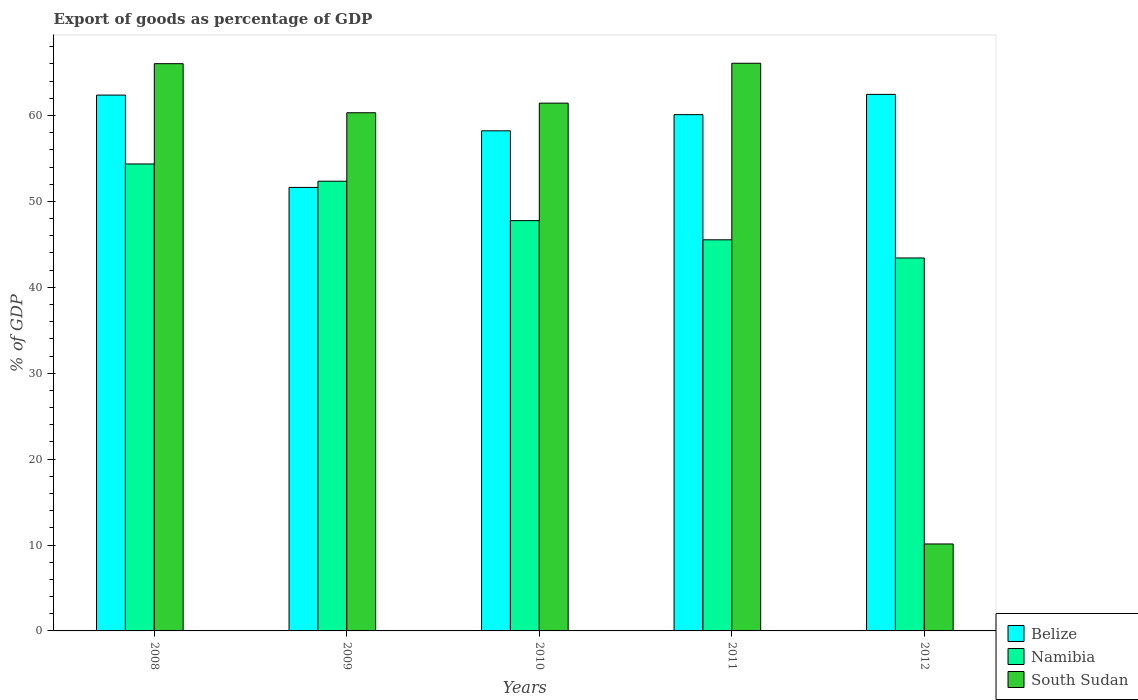How many different coloured bars are there?
Your response must be concise. 3. How many groups of bars are there?
Keep it short and to the point. 5. Are the number of bars per tick equal to the number of legend labels?
Your answer should be compact. Yes. Are the number of bars on each tick of the X-axis equal?
Ensure brevity in your answer.  Yes. How many bars are there on the 2nd tick from the right?
Keep it short and to the point. 3. What is the label of the 2nd group of bars from the left?
Ensure brevity in your answer.  2009. In how many cases, is the number of bars for a given year not equal to the number of legend labels?
Your response must be concise. 0. What is the export of goods as percentage of GDP in South Sudan in 2010?
Ensure brevity in your answer.  61.43. Across all years, what is the maximum export of goods as percentage of GDP in South Sudan?
Your answer should be very brief. 66.08. Across all years, what is the minimum export of goods as percentage of GDP in Namibia?
Keep it short and to the point. 43.41. In which year was the export of goods as percentage of GDP in South Sudan maximum?
Offer a terse response. 2011. What is the total export of goods as percentage of GDP in Namibia in the graph?
Your answer should be compact. 243.4. What is the difference between the export of goods as percentage of GDP in Namibia in 2008 and that in 2011?
Provide a short and direct response. 8.83. What is the difference between the export of goods as percentage of GDP in Belize in 2011 and the export of goods as percentage of GDP in South Sudan in 2010?
Your answer should be compact. -1.34. What is the average export of goods as percentage of GDP in Belize per year?
Your answer should be very brief. 58.95. In the year 2008, what is the difference between the export of goods as percentage of GDP in Namibia and export of goods as percentage of GDP in Belize?
Your response must be concise. -8.02. What is the ratio of the export of goods as percentage of GDP in Belize in 2009 to that in 2011?
Your response must be concise. 0.86. Is the difference between the export of goods as percentage of GDP in Namibia in 2011 and 2012 greater than the difference between the export of goods as percentage of GDP in Belize in 2011 and 2012?
Your answer should be very brief. Yes. What is the difference between the highest and the second highest export of goods as percentage of GDP in Namibia?
Keep it short and to the point. 2.01. What is the difference between the highest and the lowest export of goods as percentage of GDP in Namibia?
Ensure brevity in your answer.  10.94. In how many years, is the export of goods as percentage of GDP in South Sudan greater than the average export of goods as percentage of GDP in South Sudan taken over all years?
Your response must be concise. 4. Is the sum of the export of goods as percentage of GDP in Namibia in 2008 and 2010 greater than the maximum export of goods as percentage of GDP in Belize across all years?
Ensure brevity in your answer.  Yes. What does the 1st bar from the left in 2010 represents?
Provide a short and direct response. Belize. What does the 2nd bar from the right in 2009 represents?
Your response must be concise. Namibia. Is it the case that in every year, the sum of the export of goods as percentage of GDP in South Sudan and export of goods as percentage of GDP in Belize is greater than the export of goods as percentage of GDP in Namibia?
Make the answer very short. Yes. Are all the bars in the graph horizontal?
Your answer should be very brief. No. How many years are there in the graph?
Your answer should be very brief. 5. Does the graph contain grids?
Keep it short and to the point. No. Where does the legend appear in the graph?
Offer a very short reply. Bottom right. How many legend labels are there?
Keep it short and to the point. 3. How are the legend labels stacked?
Provide a succinct answer. Vertical. What is the title of the graph?
Provide a short and direct response. Export of goods as percentage of GDP. Does "Indonesia" appear as one of the legend labels in the graph?
Keep it short and to the point. No. What is the label or title of the Y-axis?
Give a very brief answer. % of GDP. What is the % of GDP in Belize in 2008?
Your response must be concise. 62.37. What is the % of GDP of Namibia in 2008?
Make the answer very short. 54.35. What is the % of GDP in South Sudan in 2008?
Your answer should be very brief. 66.03. What is the % of GDP in Belize in 2009?
Your answer should be very brief. 51.62. What is the % of GDP in Namibia in 2009?
Your answer should be very brief. 52.35. What is the % of GDP of South Sudan in 2009?
Your response must be concise. 60.31. What is the % of GDP in Belize in 2010?
Ensure brevity in your answer.  58.21. What is the % of GDP in Namibia in 2010?
Ensure brevity in your answer.  47.76. What is the % of GDP in South Sudan in 2010?
Offer a very short reply. 61.43. What is the % of GDP of Belize in 2011?
Provide a succinct answer. 60.09. What is the % of GDP of Namibia in 2011?
Keep it short and to the point. 45.53. What is the % of GDP of South Sudan in 2011?
Keep it short and to the point. 66.08. What is the % of GDP in Belize in 2012?
Your answer should be very brief. 62.45. What is the % of GDP of Namibia in 2012?
Your response must be concise. 43.41. What is the % of GDP of South Sudan in 2012?
Provide a short and direct response. 10.12. Across all years, what is the maximum % of GDP in Belize?
Provide a succinct answer. 62.45. Across all years, what is the maximum % of GDP of Namibia?
Offer a terse response. 54.35. Across all years, what is the maximum % of GDP in South Sudan?
Your response must be concise. 66.08. Across all years, what is the minimum % of GDP in Belize?
Make the answer very short. 51.62. Across all years, what is the minimum % of GDP of Namibia?
Make the answer very short. 43.41. Across all years, what is the minimum % of GDP of South Sudan?
Keep it short and to the point. 10.12. What is the total % of GDP in Belize in the graph?
Ensure brevity in your answer.  294.75. What is the total % of GDP of Namibia in the graph?
Ensure brevity in your answer.  243.4. What is the total % of GDP in South Sudan in the graph?
Ensure brevity in your answer.  263.97. What is the difference between the % of GDP in Belize in 2008 and that in 2009?
Your answer should be compact. 10.75. What is the difference between the % of GDP in Namibia in 2008 and that in 2009?
Offer a very short reply. 2.01. What is the difference between the % of GDP in South Sudan in 2008 and that in 2009?
Offer a very short reply. 5.71. What is the difference between the % of GDP in Belize in 2008 and that in 2010?
Your answer should be compact. 4.16. What is the difference between the % of GDP of Namibia in 2008 and that in 2010?
Keep it short and to the point. 6.6. What is the difference between the % of GDP of South Sudan in 2008 and that in 2010?
Offer a terse response. 4.59. What is the difference between the % of GDP in Belize in 2008 and that in 2011?
Provide a succinct answer. 2.28. What is the difference between the % of GDP of Namibia in 2008 and that in 2011?
Keep it short and to the point. 8.83. What is the difference between the % of GDP of South Sudan in 2008 and that in 2011?
Keep it short and to the point. -0.05. What is the difference between the % of GDP in Belize in 2008 and that in 2012?
Give a very brief answer. -0.08. What is the difference between the % of GDP of Namibia in 2008 and that in 2012?
Keep it short and to the point. 10.94. What is the difference between the % of GDP in South Sudan in 2008 and that in 2012?
Offer a terse response. 55.91. What is the difference between the % of GDP of Belize in 2009 and that in 2010?
Give a very brief answer. -6.59. What is the difference between the % of GDP of Namibia in 2009 and that in 2010?
Make the answer very short. 4.59. What is the difference between the % of GDP of South Sudan in 2009 and that in 2010?
Offer a terse response. -1.12. What is the difference between the % of GDP in Belize in 2009 and that in 2011?
Offer a very short reply. -8.47. What is the difference between the % of GDP of Namibia in 2009 and that in 2011?
Make the answer very short. 6.82. What is the difference between the % of GDP of South Sudan in 2009 and that in 2011?
Provide a succinct answer. -5.76. What is the difference between the % of GDP of Belize in 2009 and that in 2012?
Offer a terse response. -10.83. What is the difference between the % of GDP in Namibia in 2009 and that in 2012?
Your response must be concise. 8.94. What is the difference between the % of GDP in South Sudan in 2009 and that in 2012?
Provide a succinct answer. 50.19. What is the difference between the % of GDP of Belize in 2010 and that in 2011?
Offer a terse response. -1.88. What is the difference between the % of GDP of Namibia in 2010 and that in 2011?
Your response must be concise. 2.23. What is the difference between the % of GDP in South Sudan in 2010 and that in 2011?
Offer a very short reply. -4.64. What is the difference between the % of GDP in Belize in 2010 and that in 2012?
Your answer should be compact. -4.24. What is the difference between the % of GDP of Namibia in 2010 and that in 2012?
Keep it short and to the point. 4.35. What is the difference between the % of GDP in South Sudan in 2010 and that in 2012?
Keep it short and to the point. 51.31. What is the difference between the % of GDP in Belize in 2011 and that in 2012?
Offer a terse response. -2.36. What is the difference between the % of GDP in Namibia in 2011 and that in 2012?
Give a very brief answer. 2.12. What is the difference between the % of GDP of South Sudan in 2011 and that in 2012?
Make the answer very short. 55.95. What is the difference between the % of GDP of Belize in 2008 and the % of GDP of Namibia in 2009?
Your answer should be compact. 10.02. What is the difference between the % of GDP of Belize in 2008 and the % of GDP of South Sudan in 2009?
Offer a very short reply. 2.06. What is the difference between the % of GDP in Namibia in 2008 and the % of GDP in South Sudan in 2009?
Offer a very short reply. -5.96. What is the difference between the % of GDP in Belize in 2008 and the % of GDP in Namibia in 2010?
Provide a succinct answer. 14.61. What is the difference between the % of GDP of Belize in 2008 and the % of GDP of South Sudan in 2010?
Your answer should be compact. 0.94. What is the difference between the % of GDP in Namibia in 2008 and the % of GDP in South Sudan in 2010?
Ensure brevity in your answer.  -7.08. What is the difference between the % of GDP in Belize in 2008 and the % of GDP in Namibia in 2011?
Your answer should be compact. 16.85. What is the difference between the % of GDP in Belize in 2008 and the % of GDP in South Sudan in 2011?
Ensure brevity in your answer.  -3.7. What is the difference between the % of GDP of Namibia in 2008 and the % of GDP of South Sudan in 2011?
Make the answer very short. -11.72. What is the difference between the % of GDP of Belize in 2008 and the % of GDP of Namibia in 2012?
Provide a succinct answer. 18.96. What is the difference between the % of GDP of Belize in 2008 and the % of GDP of South Sudan in 2012?
Offer a very short reply. 52.25. What is the difference between the % of GDP in Namibia in 2008 and the % of GDP in South Sudan in 2012?
Offer a very short reply. 44.23. What is the difference between the % of GDP of Belize in 2009 and the % of GDP of Namibia in 2010?
Provide a succinct answer. 3.87. What is the difference between the % of GDP of Belize in 2009 and the % of GDP of South Sudan in 2010?
Offer a very short reply. -9.81. What is the difference between the % of GDP in Namibia in 2009 and the % of GDP in South Sudan in 2010?
Offer a very short reply. -9.09. What is the difference between the % of GDP in Belize in 2009 and the % of GDP in Namibia in 2011?
Your response must be concise. 6.1. What is the difference between the % of GDP in Belize in 2009 and the % of GDP in South Sudan in 2011?
Your answer should be compact. -14.45. What is the difference between the % of GDP of Namibia in 2009 and the % of GDP of South Sudan in 2011?
Provide a short and direct response. -13.73. What is the difference between the % of GDP of Belize in 2009 and the % of GDP of Namibia in 2012?
Your answer should be very brief. 8.21. What is the difference between the % of GDP of Belize in 2009 and the % of GDP of South Sudan in 2012?
Provide a succinct answer. 41.5. What is the difference between the % of GDP in Namibia in 2009 and the % of GDP in South Sudan in 2012?
Your answer should be compact. 42.23. What is the difference between the % of GDP of Belize in 2010 and the % of GDP of Namibia in 2011?
Offer a very short reply. 12.69. What is the difference between the % of GDP of Belize in 2010 and the % of GDP of South Sudan in 2011?
Offer a terse response. -7.86. What is the difference between the % of GDP in Namibia in 2010 and the % of GDP in South Sudan in 2011?
Make the answer very short. -18.32. What is the difference between the % of GDP in Belize in 2010 and the % of GDP in Namibia in 2012?
Offer a terse response. 14.8. What is the difference between the % of GDP in Belize in 2010 and the % of GDP in South Sudan in 2012?
Your answer should be compact. 48.09. What is the difference between the % of GDP of Namibia in 2010 and the % of GDP of South Sudan in 2012?
Make the answer very short. 37.64. What is the difference between the % of GDP of Belize in 2011 and the % of GDP of Namibia in 2012?
Your answer should be compact. 16.68. What is the difference between the % of GDP in Belize in 2011 and the % of GDP in South Sudan in 2012?
Make the answer very short. 49.97. What is the difference between the % of GDP in Namibia in 2011 and the % of GDP in South Sudan in 2012?
Your answer should be compact. 35.4. What is the average % of GDP in Belize per year?
Your answer should be compact. 58.95. What is the average % of GDP of Namibia per year?
Provide a short and direct response. 48.68. What is the average % of GDP in South Sudan per year?
Give a very brief answer. 52.79. In the year 2008, what is the difference between the % of GDP of Belize and % of GDP of Namibia?
Your response must be concise. 8.02. In the year 2008, what is the difference between the % of GDP in Belize and % of GDP in South Sudan?
Give a very brief answer. -3.66. In the year 2008, what is the difference between the % of GDP in Namibia and % of GDP in South Sudan?
Offer a terse response. -11.67. In the year 2009, what is the difference between the % of GDP in Belize and % of GDP in Namibia?
Keep it short and to the point. -0.72. In the year 2009, what is the difference between the % of GDP of Belize and % of GDP of South Sudan?
Your answer should be very brief. -8.69. In the year 2009, what is the difference between the % of GDP of Namibia and % of GDP of South Sudan?
Provide a succinct answer. -7.97. In the year 2010, what is the difference between the % of GDP of Belize and % of GDP of Namibia?
Provide a short and direct response. 10.46. In the year 2010, what is the difference between the % of GDP of Belize and % of GDP of South Sudan?
Make the answer very short. -3.22. In the year 2010, what is the difference between the % of GDP in Namibia and % of GDP in South Sudan?
Keep it short and to the point. -13.68. In the year 2011, what is the difference between the % of GDP of Belize and % of GDP of Namibia?
Provide a short and direct response. 14.57. In the year 2011, what is the difference between the % of GDP in Belize and % of GDP in South Sudan?
Ensure brevity in your answer.  -5.98. In the year 2011, what is the difference between the % of GDP of Namibia and % of GDP of South Sudan?
Give a very brief answer. -20.55. In the year 2012, what is the difference between the % of GDP in Belize and % of GDP in Namibia?
Provide a short and direct response. 19.04. In the year 2012, what is the difference between the % of GDP of Belize and % of GDP of South Sudan?
Your answer should be compact. 52.33. In the year 2012, what is the difference between the % of GDP of Namibia and % of GDP of South Sudan?
Make the answer very short. 33.29. What is the ratio of the % of GDP in Belize in 2008 to that in 2009?
Give a very brief answer. 1.21. What is the ratio of the % of GDP of Namibia in 2008 to that in 2009?
Your response must be concise. 1.04. What is the ratio of the % of GDP in South Sudan in 2008 to that in 2009?
Provide a short and direct response. 1.09. What is the ratio of the % of GDP in Belize in 2008 to that in 2010?
Offer a terse response. 1.07. What is the ratio of the % of GDP of Namibia in 2008 to that in 2010?
Provide a succinct answer. 1.14. What is the ratio of the % of GDP of South Sudan in 2008 to that in 2010?
Provide a succinct answer. 1.07. What is the ratio of the % of GDP in Belize in 2008 to that in 2011?
Make the answer very short. 1.04. What is the ratio of the % of GDP in Namibia in 2008 to that in 2011?
Provide a short and direct response. 1.19. What is the ratio of the % of GDP in Belize in 2008 to that in 2012?
Give a very brief answer. 1. What is the ratio of the % of GDP of Namibia in 2008 to that in 2012?
Keep it short and to the point. 1.25. What is the ratio of the % of GDP of South Sudan in 2008 to that in 2012?
Provide a short and direct response. 6.52. What is the ratio of the % of GDP of Belize in 2009 to that in 2010?
Your answer should be compact. 0.89. What is the ratio of the % of GDP of Namibia in 2009 to that in 2010?
Make the answer very short. 1.1. What is the ratio of the % of GDP in South Sudan in 2009 to that in 2010?
Keep it short and to the point. 0.98. What is the ratio of the % of GDP in Belize in 2009 to that in 2011?
Your answer should be compact. 0.86. What is the ratio of the % of GDP in Namibia in 2009 to that in 2011?
Ensure brevity in your answer.  1.15. What is the ratio of the % of GDP in South Sudan in 2009 to that in 2011?
Offer a terse response. 0.91. What is the ratio of the % of GDP in Belize in 2009 to that in 2012?
Your answer should be compact. 0.83. What is the ratio of the % of GDP in Namibia in 2009 to that in 2012?
Your answer should be very brief. 1.21. What is the ratio of the % of GDP of South Sudan in 2009 to that in 2012?
Your answer should be very brief. 5.96. What is the ratio of the % of GDP in Belize in 2010 to that in 2011?
Ensure brevity in your answer.  0.97. What is the ratio of the % of GDP of Namibia in 2010 to that in 2011?
Offer a very short reply. 1.05. What is the ratio of the % of GDP of South Sudan in 2010 to that in 2011?
Your answer should be compact. 0.93. What is the ratio of the % of GDP of Belize in 2010 to that in 2012?
Offer a terse response. 0.93. What is the ratio of the % of GDP in Namibia in 2010 to that in 2012?
Provide a short and direct response. 1.1. What is the ratio of the % of GDP of South Sudan in 2010 to that in 2012?
Your answer should be compact. 6.07. What is the ratio of the % of GDP in Belize in 2011 to that in 2012?
Make the answer very short. 0.96. What is the ratio of the % of GDP in Namibia in 2011 to that in 2012?
Offer a terse response. 1.05. What is the ratio of the % of GDP in South Sudan in 2011 to that in 2012?
Your answer should be very brief. 6.53. What is the difference between the highest and the second highest % of GDP in Belize?
Your answer should be very brief. 0.08. What is the difference between the highest and the second highest % of GDP in Namibia?
Keep it short and to the point. 2.01. What is the difference between the highest and the second highest % of GDP in South Sudan?
Give a very brief answer. 0.05. What is the difference between the highest and the lowest % of GDP in Belize?
Provide a short and direct response. 10.83. What is the difference between the highest and the lowest % of GDP of Namibia?
Offer a very short reply. 10.94. What is the difference between the highest and the lowest % of GDP in South Sudan?
Provide a short and direct response. 55.95. 